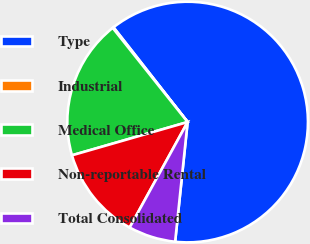Convert chart to OTSL. <chart><loc_0><loc_0><loc_500><loc_500><pie_chart><fcel>Type<fcel>Industrial<fcel>Medical Office<fcel>Non-reportable Rental<fcel>Total Consolidated<nl><fcel>62.23%<fcel>0.13%<fcel>18.76%<fcel>12.55%<fcel>6.34%<nl></chart> 